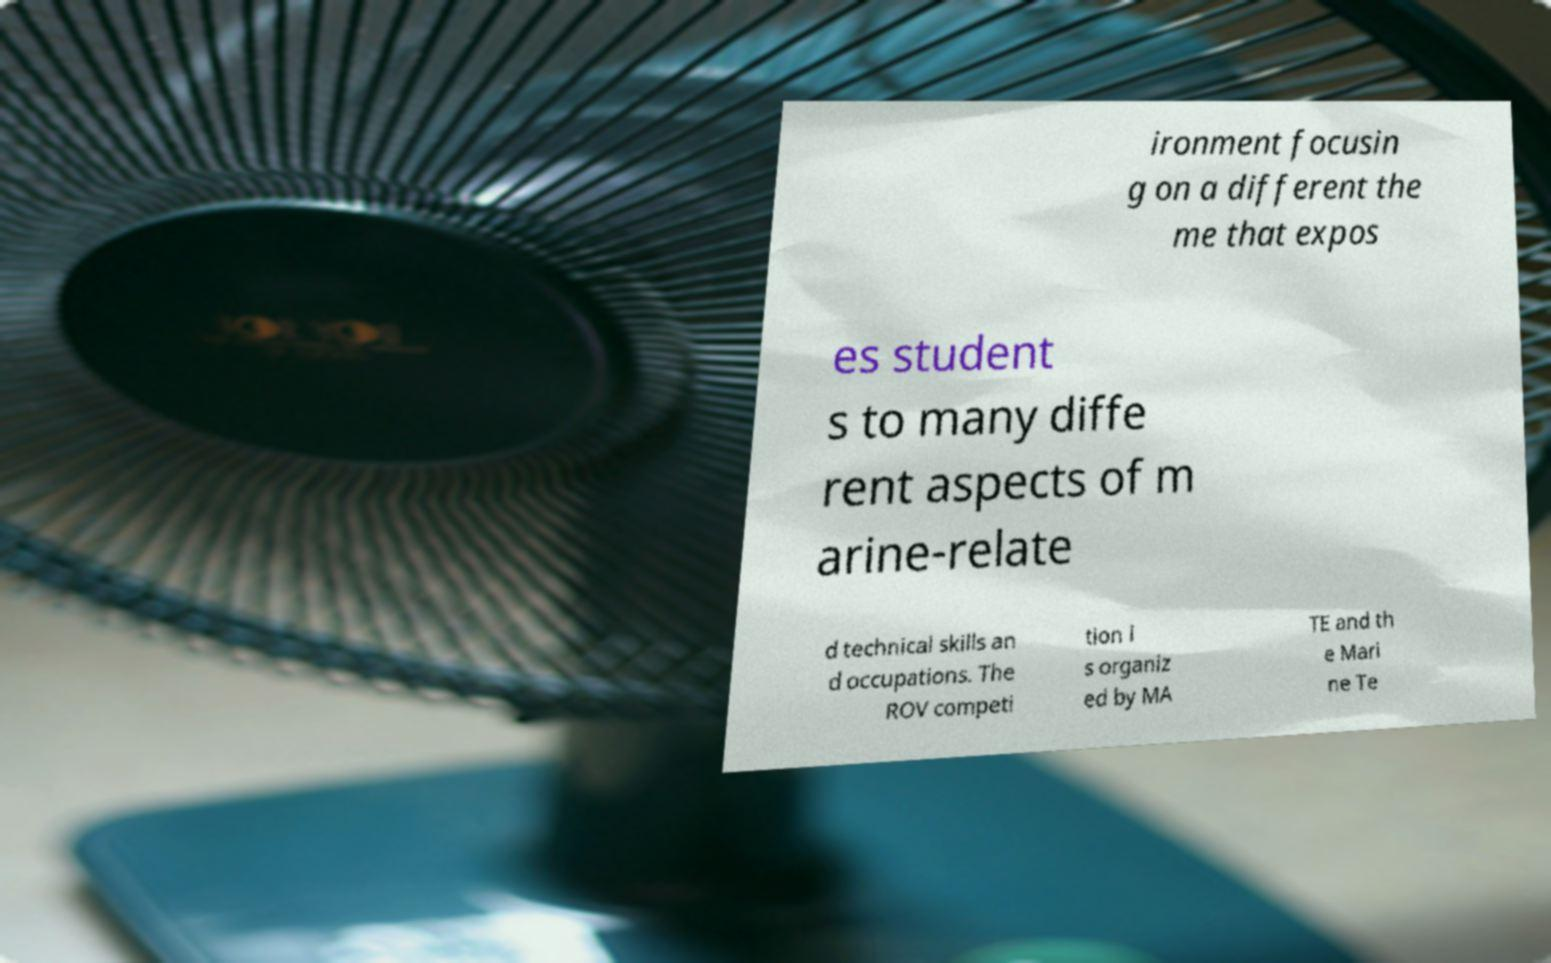Please read and relay the text visible in this image. What does it say? ironment focusin g on a different the me that expos es student s to many diffe rent aspects of m arine-relate d technical skills an d occupations. The ROV competi tion i s organiz ed by MA TE and th e Mari ne Te 